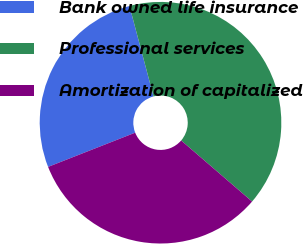<chart> <loc_0><loc_0><loc_500><loc_500><pie_chart><fcel>Bank owned life insurance<fcel>Professional services<fcel>Amortization of capitalized<nl><fcel>26.82%<fcel>40.45%<fcel>32.73%<nl></chart> 